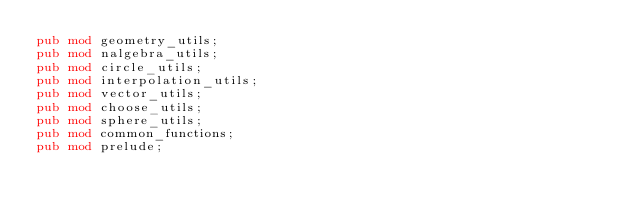<code> <loc_0><loc_0><loc_500><loc_500><_Rust_>pub mod geometry_utils;
pub mod nalgebra_utils;
pub mod circle_utils;
pub mod interpolation_utils;
pub mod vector_utils;
pub mod choose_utils;
pub mod sphere_utils;
pub mod common_functions;
pub mod prelude;</code> 